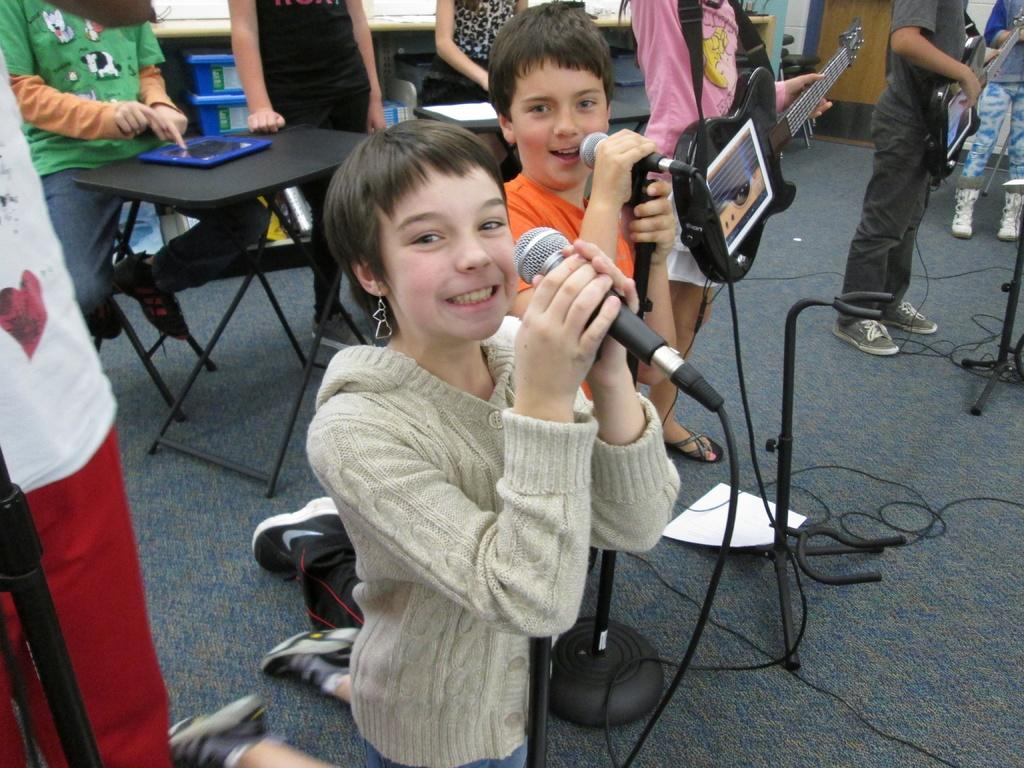Who are the people in the image? There is a girl and a boy in the image. What are the girl and boy doing in the image? They are both singing in the image. How are they amplifying their voices? They are using microphones in the image. Is there anyone else in the image playing an instrument? Yes, there is a person holding a guitar in the image. How many sugar packets are on the table in the image? There is no table or sugar packets present in the image. Can you see any passengers in the image? There are no passengers or transportation-related elements in the image. 